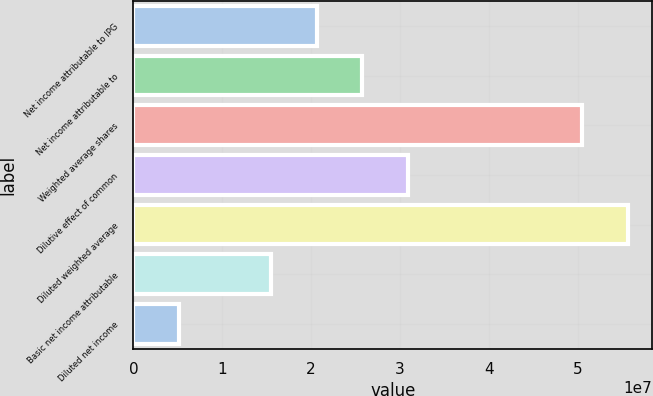Convert chart to OTSL. <chart><loc_0><loc_0><loc_500><loc_500><bar_chart><fcel>Net income attributable to IPG<fcel>Net income attributable to<fcel>Weighted average shares<fcel>Dilutive effect of common<fcel>Diluted weighted average<fcel>Basic net income attributable<fcel>Diluted net income<nl><fcel>2.06145e+07<fcel>2.57682e+07<fcel>5.04771e+07<fcel>3.09218e+07<fcel>5.56307e+07<fcel>1.54609e+07<fcel>5.15364e+06<nl></chart> 